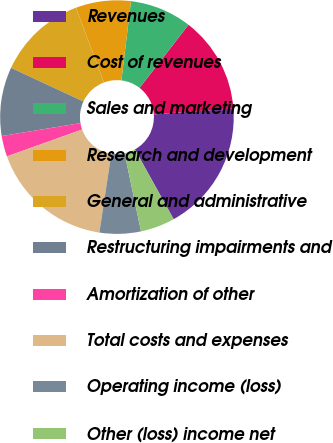Convert chart. <chart><loc_0><loc_0><loc_500><loc_500><pie_chart><fcel>Revenues<fcel>Cost of revenues<fcel>Sales and marketing<fcel>Research and development<fcel>General and administrative<fcel>Restructuring impairments and<fcel>Amortization of other<fcel>Total costs and expenses<fcel>Operating income (loss)<fcel>Other (loss) income net<nl><fcel>18.1%<fcel>13.33%<fcel>8.57%<fcel>7.62%<fcel>12.38%<fcel>9.52%<fcel>2.86%<fcel>17.14%<fcel>5.71%<fcel>4.76%<nl></chart> 